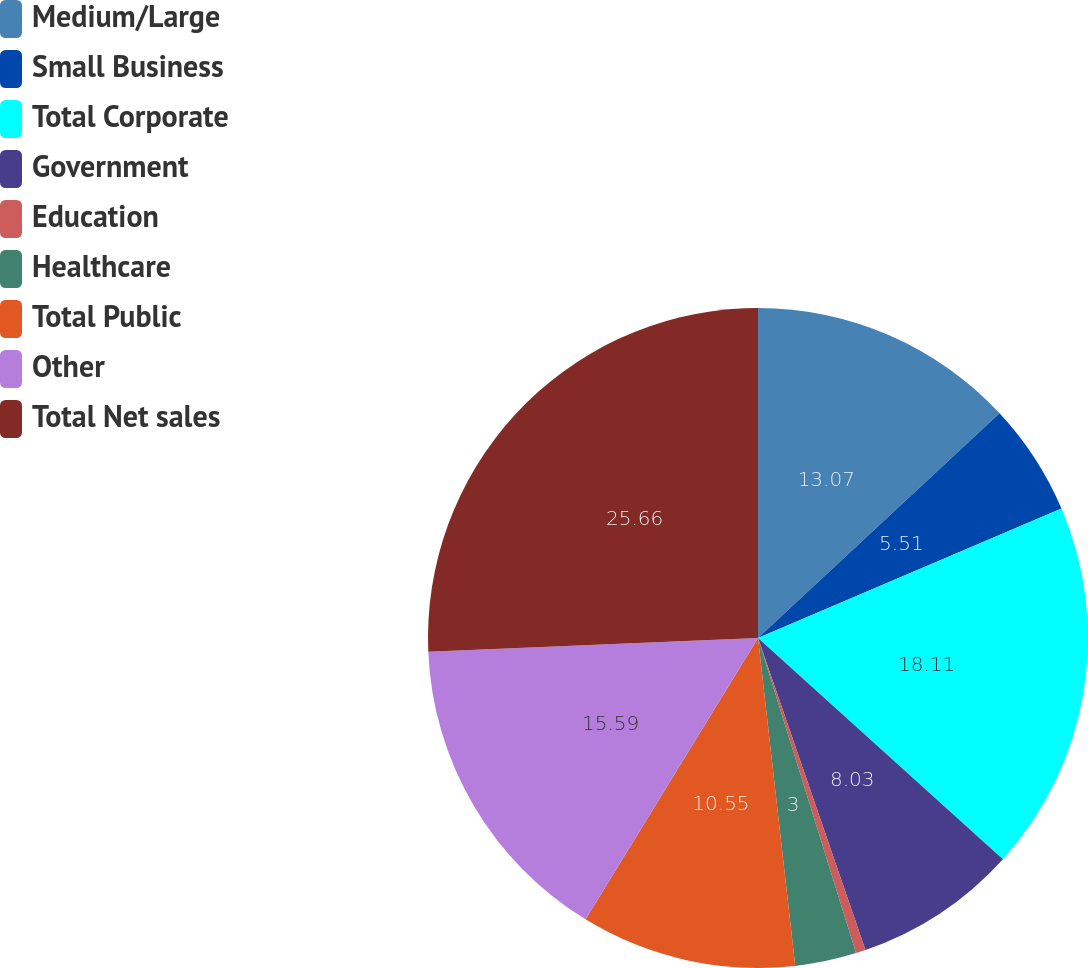Convert chart. <chart><loc_0><loc_0><loc_500><loc_500><pie_chart><fcel>Medium/Large<fcel>Small Business<fcel>Total Corporate<fcel>Government<fcel>Education<fcel>Healthcare<fcel>Total Public<fcel>Other<fcel>Total Net sales<nl><fcel>13.07%<fcel>5.51%<fcel>18.11%<fcel>8.03%<fcel>0.48%<fcel>3.0%<fcel>10.55%<fcel>15.59%<fcel>25.66%<nl></chart> 